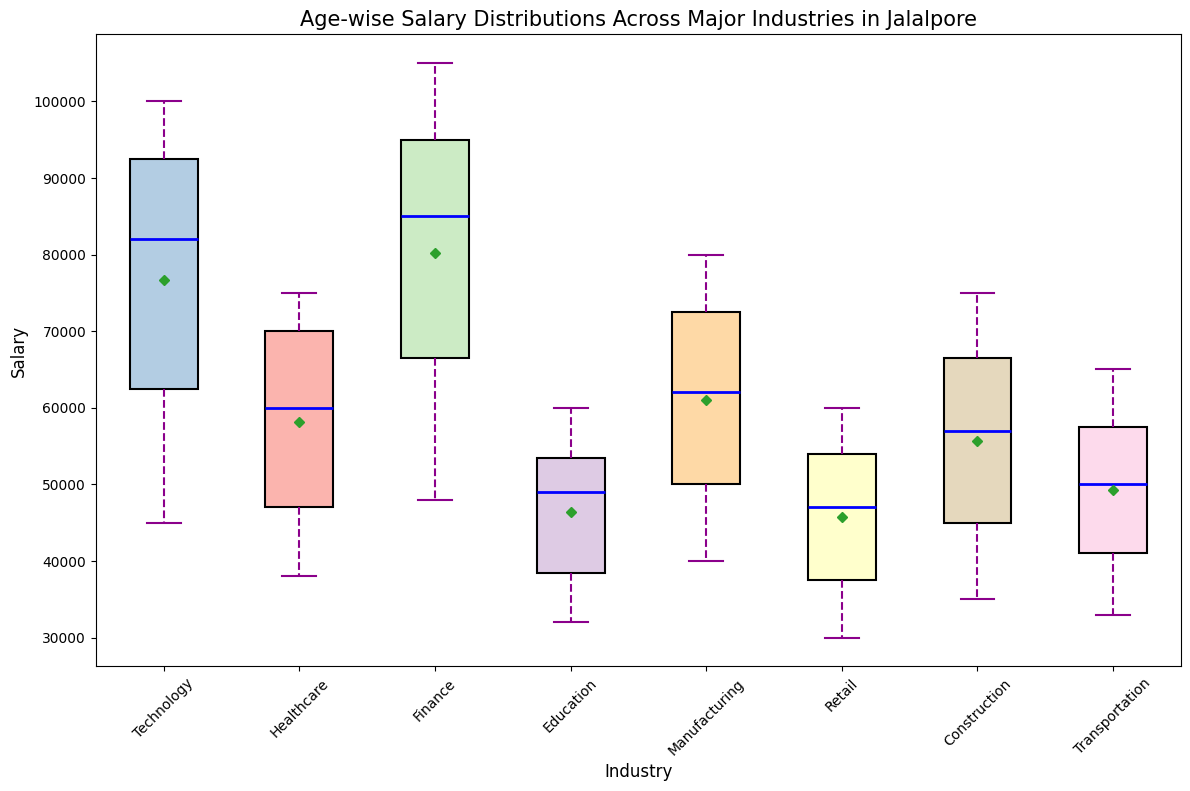Which industry has the highest median salary? To find the industry with the highest median salary, look for the industry where the box plot's median line (blue line) is the highest among all.
Answer: Finance Which industry has the lowest mean salary? The mean is indicated by the green diamond marker on the box plot. Identify the industry where this marker is positioned the lowest.
Answer: Retail What is the median salary in the Technology industry? Check the blue line inside the box for the Technology industry's box plot. The blue line represents the median salary.
Answer: 82,000 What is the range of salaries in the Healthcare industry? The range is determined by the distance between the highest and lowest whiskers of the box plot for the Healthcare industry.
Answer: 38,000 to 75,000 Which industry shows the greatest variability in salaries? Variability is indicated by the length of the whiskers and size of the box. The industry with the longest whiskers and largest box height shows the greatest variability.
Answer: Finance In which industry are the upper and lower quartiles the closest to each other? The quartiles are shown by the top and bottom of the box. The industry with the smallest box height has the closest quartiles.
Answer: Retail How do the mean salaries of the Education and Manufacturing industries compare? Observe the position of the green diamond markers for both Education and Manufacturing to see which one is higher or lower.
Answer: Manufacturing is higher What is the interquartile range (IQR) for the Construction industry? The IQR is the distance between the top (75th percentile) and bottom (25th percentile) of the box in the box plot. Measure this distance for the Construction industry.
Answer: 40,000 to 69,000 (29,000) Which industry has outliers, if any? Check for points that fall outside the whiskers of the box plots. Identify the industry where such points are present, marked typically as small circles or dots.
Answer: None in the given data What is the median salary difference between the Finance and Retail industries? Find the median salary for both Finance (blue line in the Finance box) and Retail (blue line in the Retail box) and calculate the difference.
Answer: 85,000 - 47,000 = 38,000 